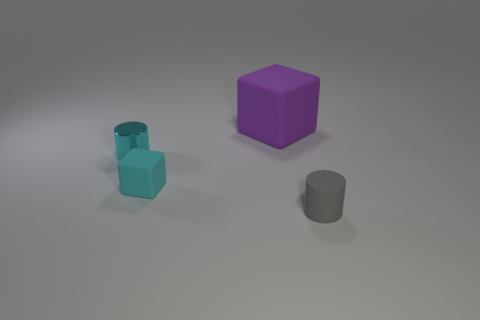Are there any gray rubber objects behind the tiny thing in front of the tiny rubber object that is behind the gray rubber cylinder? no 